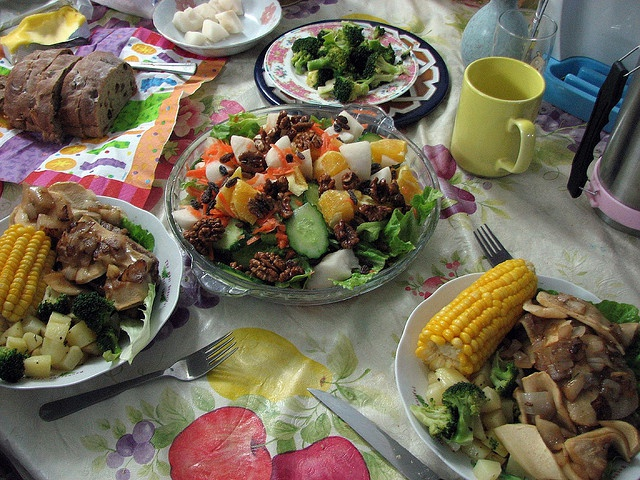Describe the objects in this image and their specific colors. I can see dining table in gray, darkgray, olive, and black tones, bowl in gray, black, darkgreen, and maroon tones, bowl in gray, black, olive, tan, and maroon tones, cup in gray and olive tones, and bowl in gray, darkgray, and lightgray tones in this image. 